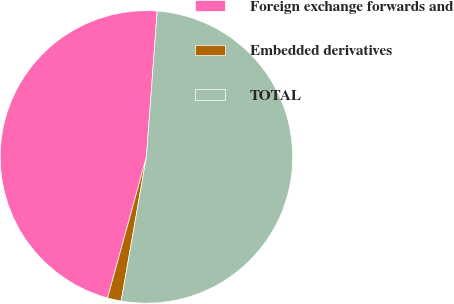<chart> <loc_0><loc_0><loc_500><loc_500><pie_chart><fcel>Foreign exchange forwards and<fcel>Embedded derivatives<fcel>TOTAL<nl><fcel>46.89%<fcel>1.52%<fcel>51.58%<nl></chart> 